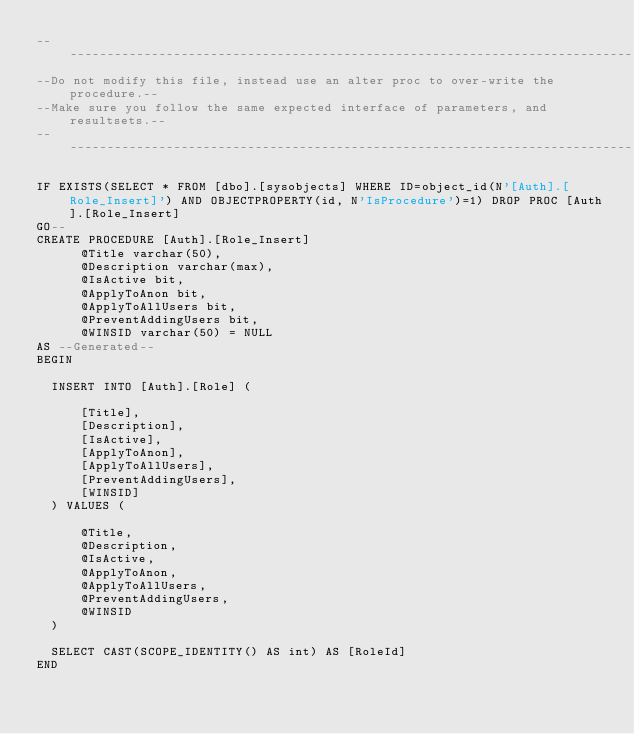<code> <loc_0><loc_0><loc_500><loc_500><_SQL_>-----------------------------------------------------------------------------------
--Do not modify this file, instead use an alter proc to over-write the procedure.--
--Make sure you follow the same expected interface of parameters, and resultsets.--
-----------------------------------------------------------------------------------

IF EXISTS(SELECT * FROM [dbo].[sysobjects] WHERE ID=object_id(N'[Auth].[Role_Insert]') AND OBJECTPROPERTY(id, N'IsProcedure')=1) DROP PROC [Auth].[Role_Insert]
GO--
CREATE PROCEDURE [Auth].[Role_Insert]
			@Title varchar(50),
			@Description varchar(max),
			@IsActive bit,
			@ApplyToAnon bit,
			@ApplyToAllUsers bit,
			@PreventAddingUsers bit,
			@WINSID varchar(50) = NULL
AS --Generated--
BEGIN

	INSERT INTO [Auth].[Role] (

			[Title],
			[Description],
			[IsActive],
			[ApplyToAnon],
			[ApplyToAllUsers],
			[PreventAddingUsers],
			[WINSID]
	) VALUES (

			@Title,
			@Description,
			@IsActive,
			@ApplyToAnon,
			@ApplyToAllUsers,
			@PreventAddingUsers,
			@WINSID
	)

	SELECT CAST(SCOPE_IDENTITY() AS int) AS [RoleId]
END</code> 